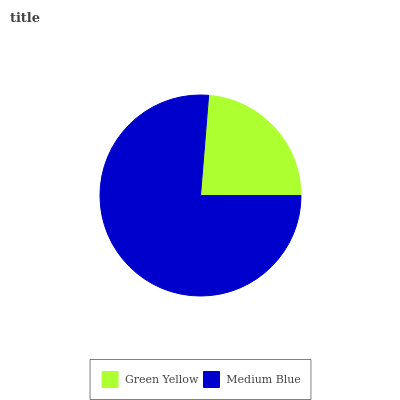Is Green Yellow the minimum?
Answer yes or no. Yes. Is Medium Blue the maximum?
Answer yes or no. Yes. Is Medium Blue the minimum?
Answer yes or no. No. Is Medium Blue greater than Green Yellow?
Answer yes or no. Yes. Is Green Yellow less than Medium Blue?
Answer yes or no. Yes. Is Green Yellow greater than Medium Blue?
Answer yes or no. No. Is Medium Blue less than Green Yellow?
Answer yes or no. No. Is Medium Blue the high median?
Answer yes or no. Yes. Is Green Yellow the low median?
Answer yes or no. Yes. Is Green Yellow the high median?
Answer yes or no. No. Is Medium Blue the low median?
Answer yes or no. No. 